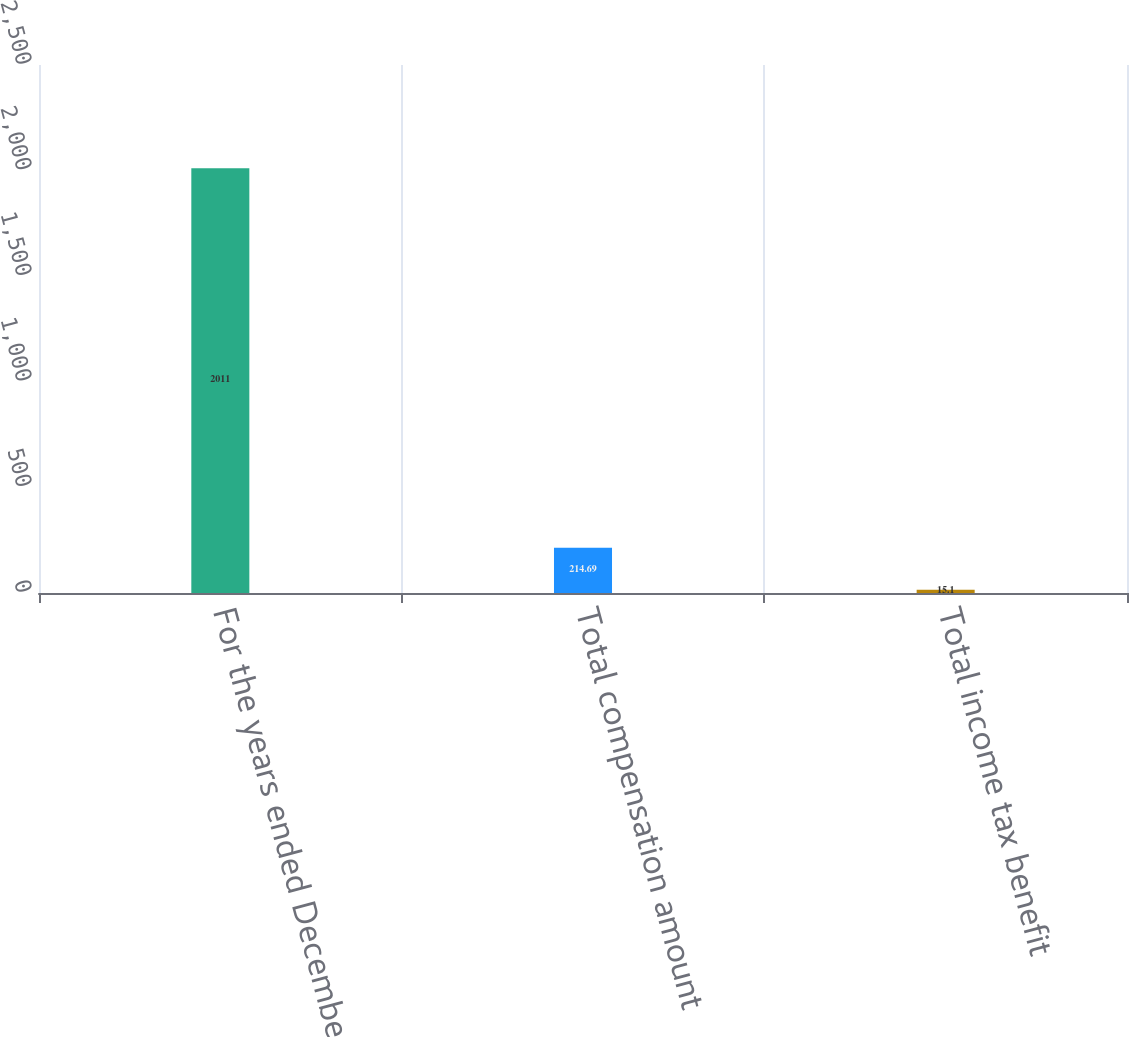<chart> <loc_0><loc_0><loc_500><loc_500><bar_chart><fcel>For the years ended December<fcel>Total compensation amount<fcel>Total income tax benefit<nl><fcel>2011<fcel>214.69<fcel>15.1<nl></chart> 